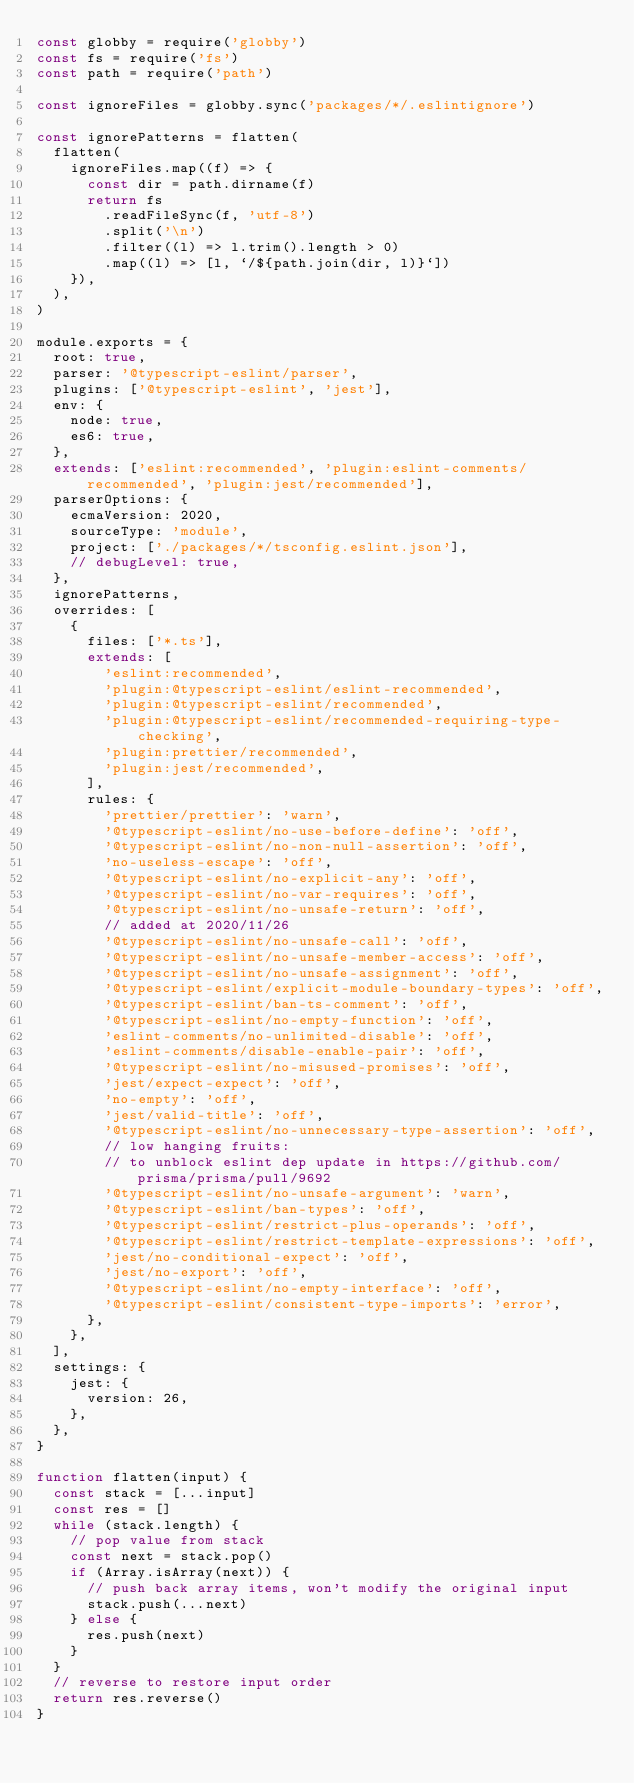Convert code to text. <code><loc_0><loc_0><loc_500><loc_500><_JavaScript_>const globby = require('globby')
const fs = require('fs')
const path = require('path')

const ignoreFiles = globby.sync('packages/*/.eslintignore')

const ignorePatterns = flatten(
  flatten(
    ignoreFiles.map((f) => {
      const dir = path.dirname(f)
      return fs
        .readFileSync(f, 'utf-8')
        .split('\n')
        .filter((l) => l.trim().length > 0)
        .map((l) => [l, `/${path.join(dir, l)}`])
    }),
  ),
)

module.exports = {
  root: true,
  parser: '@typescript-eslint/parser',
  plugins: ['@typescript-eslint', 'jest'],
  env: {
    node: true,
    es6: true,
  },
  extends: ['eslint:recommended', 'plugin:eslint-comments/recommended', 'plugin:jest/recommended'],
  parserOptions: {
    ecmaVersion: 2020,
    sourceType: 'module',
    project: ['./packages/*/tsconfig.eslint.json'],
    // debugLevel: true,
  },
  ignorePatterns,
  overrides: [
    {
      files: ['*.ts'],
      extends: [
        'eslint:recommended',
        'plugin:@typescript-eslint/eslint-recommended',
        'plugin:@typescript-eslint/recommended',
        'plugin:@typescript-eslint/recommended-requiring-type-checking',
        'plugin:prettier/recommended',
        'plugin:jest/recommended',
      ],
      rules: {
        'prettier/prettier': 'warn',
        '@typescript-eslint/no-use-before-define': 'off',
        '@typescript-eslint/no-non-null-assertion': 'off',
        'no-useless-escape': 'off',
        '@typescript-eslint/no-explicit-any': 'off',
        '@typescript-eslint/no-var-requires': 'off',
        '@typescript-eslint/no-unsafe-return': 'off',
        // added at 2020/11/26
        '@typescript-eslint/no-unsafe-call': 'off',
        '@typescript-eslint/no-unsafe-member-access': 'off',
        '@typescript-eslint/no-unsafe-assignment': 'off',
        '@typescript-eslint/explicit-module-boundary-types': 'off',
        '@typescript-eslint/ban-ts-comment': 'off',
        '@typescript-eslint/no-empty-function': 'off',
        'eslint-comments/no-unlimited-disable': 'off',
        'eslint-comments/disable-enable-pair': 'off',
        '@typescript-eslint/no-misused-promises': 'off',
        'jest/expect-expect': 'off',
        'no-empty': 'off',
        'jest/valid-title': 'off',
        '@typescript-eslint/no-unnecessary-type-assertion': 'off',
        // low hanging fruits:
        // to unblock eslint dep update in https://github.com/prisma/prisma/pull/9692
        '@typescript-eslint/no-unsafe-argument': 'warn',
        '@typescript-eslint/ban-types': 'off',
        '@typescript-eslint/restrict-plus-operands': 'off',
        '@typescript-eslint/restrict-template-expressions': 'off',
        'jest/no-conditional-expect': 'off',
        'jest/no-export': 'off',
        '@typescript-eslint/no-empty-interface': 'off',
        '@typescript-eslint/consistent-type-imports': 'error',
      },
    },
  ],
  settings: {
    jest: {
      version: 26,
    },
  },
}

function flatten(input) {
  const stack = [...input]
  const res = []
  while (stack.length) {
    // pop value from stack
    const next = stack.pop()
    if (Array.isArray(next)) {
      // push back array items, won't modify the original input
      stack.push(...next)
    } else {
      res.push(next)
    }
  }
  // reverse to restore input order
  return res.reverse()
}
</code> 